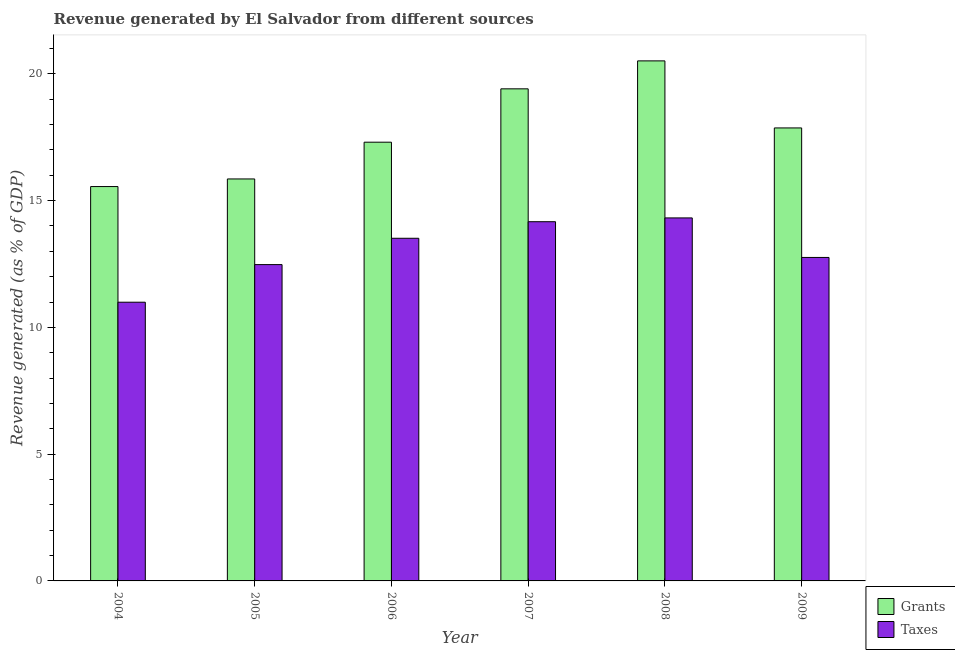How many different coloured bars are there?
Provide a succinct answer. 2. Are the number of bars on each tick of the X-axis equal?
Your answer should be very brief. Yes. How many bars are there on the 4th tick from the left?
Your response must be concise. 2. In how many cases, is the number of bars for a given year not equal to the number of legend labels?
Your answer should be very brief. 0. What is the revenue generated by taxes in 2006?
Offer a very short reply. 13.52. Across all years, what is the maximum revenue generated by taxes?
Your response must be concise. 14.32. Across all years, what is the minimum revenue generated by grants?
Keep it short and to the point. 15.56. What is the total revenue generated by taxes in the graph?
Offer a very short reply. 78.23. What is the difference between the revenue generated by grants in 2007 and that in 2009?
Your answer should be compact. 1.54. What is the difference between the revenue generated by grants in 2006 and the revenue generated by taxes in 2007?
Provide a succinct answer. -2.11. What is the average revenue generated by taxes per year?
Offer a terse response. 13.04. In the year 2004, what is the difference between the revenue generated by grants and revenue generated by taxes?
Provide a succinct answer. 0. What is the ratio of the revenue generated by taxes in 2005 to that in 2009?
Provide a short and direct response. 0.98. Is the revenue generated by taxes in 2006 less than that in 2009?
Provide a succinct answer. No. What is the difference between the highest and the second highest revenue generated by taxes?
Give a very brief answer. 0.15. What is the difference between the highest and the lowest revenue generated by grants?
Make the answer very short. 4.96. In how many years, is the revenue generated by grants greater than the average revenue generated by grants taken over all years?
Make the answer very short. 3. Is the sum of the revenue generated by grants in 2006 and 2009 greater than the maximum revenue generated by taxes across all years?
Provide a succinct answer. Yes. What does the 2nd bar from the left in 2007 represents?
Provide a succinct answer. Taxes. What does the 1st bar from the right in 2008 represents?
Offer a very short reply. Taxes. How many bars are there?
Ensure brevity in your answer.  12. Are all the bars in the graph horizontal?
Make the answer very short. No. How many years are there in the graph?
Your response must be concise. 6. Are the values on the major ticks of Y-axis written in scientific E-notation?
Ensure brevity in your answer.  No. Does the graph contain grids?
Your answer should be compact. No. How are the legend labels stacked?
Provide a succinct answer. Vertical. What is the title of the graph?
Give a very brief answer. Revenue generated by El Salvador from different sources. What is the label or title of the X-axis?
Offer a terse response. Year. What is the label or title of the Y-axis?
Offer a very short reply. Revenue generated (as % of GDP). What is the Revenue generated (as % of GDP) of Grants in 2004?
Your answer should be very brief. 15.56. What is the Revenue generated (as % of GDP) in Taxes in 2004?
Keep it short and to the point. 10.99. What is the Revenue generated (as % of GDP) in Grants in 2005?
Keep it short and to the point. 15.86. What is the Revenue generated (as % of GDP) of Taxes in 2005?
Give a very brief answer. 12.48. What is the Revenue generated (as % of GDP) of Grants in 2006?
Keep it short and to the point. 17.31. What is the Revenue generated (as % of GDP) in Taxes in 2006?
Give a very brief answer. 13.52. What is the Revenue generated (as % of GDP) of Grants in 2007?
Provide a short and direct response. 19.41. What is the Revenue generated (as % of GDP) in Taxes in 2007?
Your answer should be compact. 14.17. What is the Revenue generated (as % of GDP) of Grants in 2008?
Offer a terse response. 20.51. What is the Revenue generated (as % of GDP) in Taxes in 2008?
Your answer should be very brief. 14.32. What is the Revenue generated (as % of GDP) of Grants in 2009?
Keep it short and to the point. 17.87. What is the Revenue generated (as % of GDP) of Taxes in 2009?
Ensure brevity in your answer.  12.76. Across all years, what is the maximum Revenue generated (as % of GDP) in Grants?
Offer a very short reply. 20.51. Across all years, what is the maximum Revenue generated (as % of GDP) in Taxes?
Your answer should be compact. 14.32. Across all years, what is the minimum Revenue generated (as % of GDP) in Grants?
Offer a terse response. 15.56. Across all years, what is the minimum Revenue generated (as % of GDP) of Taxes?
Keep it short and to the point. 10.99. What is the total Revenue generated (as % of GDP) in Grants in the graph?
Your answer should be very brief. 106.51. What is the total Revenue generated (as % of GDP) in Taxes in the graph?
Give a very brief answer. 78.23. What is the difference between the Revenue generated (as % of GDP) of Taxes in 2004 and that in 2005?
Keep it short and to the point. -1.48. What is the difference between the Revenue generated (as % of GDP) in Grants in 2004 and that in 2006?
Provide a succinct answer. -1.75. What is the difference between the Revenue generated (as % of GDP) in Taxes in 2004 and that in 2006?
Keep it short and to the point. -2.52. What is the difference between the Revenue generated (as % of GDP) of Grants in 2004 and that in 2007?
Ensure brevity in your answer.  -3.85. What is the difference between the Revenue generated (as % of GDP) in Taxes in 2004 and that in 2007?
Your response must be concise. -3.18. What is the difference between the Revenue generated (as % of GDP) in Grants in 2004 and that in 2008?
Provide a short and direct response. -4.96. What is the difference between the Revenue generated (as % of GDP) in Taxes in 2004 and that in 2008?
Give a very brief answer. -3.32. What is the difference between the Revenue generated (as % of GDP) in Grants in 2004 and that in 2009?
Provide a short and direct response. -2.31. What is the difference between the Revenue generated (as % of GDP) in Taxes in 2004 and that in 2009?
Keep it short and to the point. -1.77. What is the difference between the Revenue generated (as % of GDP) of Grants in 2005 and that in 2006?
Provide a short and direct response. -1.45. What is the difference between the Revenue generated (as % of GDP) of Taxes in 2005 and that in 2006?
Make the answer very short. -1.04. What is the difference between the Revenue generated (as % of GDP) in Grants in 2005 and that in 2007?
Keep it short and to the point. -3.55. What is the difference between the Revenue generated (as % of GDP) of Taxes in 2005 and that in 2007?
Give a very brief answer. -1.69. What is the difference between the Revenue generated (as % of GDP) of Grants in 2005 and that in 2008?
Make the answer very short. -4.66. What is the difference between the Revenue generated (as % of GDP) of Taxes in 2005 and that in 2008?
Give a very brief answer. -1.84. What is the difference between the Revenue generated (as % of GDP) in Grants in 2005 and that in 2009?
Your answer should be very brief. -2.01. What is the difference between the Revenue generated (as % of GDP) of Taxes in 2005 and that in 2009?
Your answer should be very brief. -0.28. What is the difference between the Revenue generated (as % of GDP) of Grants in 2006 and that in 2007?
Your answer should be compact. -2.11. What is the difference between the Revenue generated (as % of GDP) in Taxes in 2006 and that in 2007?
Provide a succinct answer. -0.65. What is the difference between the Revenue generated (as % of GDP) of Grants in 2006 and that in 2008?
Provide a succinct answer. -3.21. What is the difference between the Revenue generated (as % of GDP) of Taxes in 2006 and that in 2008?
Your response must be concise. -0.8. What is the difference between the Revenue generated (as % of GDP) of Grants in 2006 and that in 2009?
Offer a terse response. -0.56. What is the difference between the Revenue generated (as % of GDP) in Taxes in 2006 and that in 2009?
Your response must be concise. 0.76. What is the difference between the Revenue generated (as % of GDP) in Grants in 2007 and that in 2008?
Offer a very short reply. -1.1. What is the difference between the Revenue generated (as % of GDP) of Taxes in 2007 and that in 2008?
Provide a succinct answer. -0.15. What is the difference between the Revenue generated (as % of GDP) in Grants in 2007 and that in 2009?
Keep it short and to the point. 1.54. What is the difference between the Revenue generated (as % of GDP) of Taxes in 2007 and that in 2009?
Your answer should be compact. 1.41. What is the difference between the Revenue generated (as % of GDP) in Grants in 2008 and that in 2009?
Offer a terse response. 2.64. What is the difference between the Revenue generated (as % of GDP) of Taxes in 2008 and that in 2009?
Keep it short and to the point. 1.56. What is the difference between the Revenue generated (as % of GDP) of Grants in 2004 and the Revenue generated (as % of GDP) of Taxes in 2005?
Give a very brief answer. 3.08. What is the difference between the Revenue generated (as % of GDP) of Grants in 2004 and the Revenue generated (as % of GDP) of Taxes in 2006?
Ensure brevity in your answer.  2.04. What is the difference between the Revenue generated (as % of GDP) of Grants in 2004 and the Revenue generated (as % of GDP) of Taxes in 2007?
Provide a succinct answer. 1.39. What is the difference between the Revenue generated (as % of GDP) of Grants in 2004 and the Revenue generated (as % of GDP) of Taxes in 2008?
Ensure brevity in your answer.  1.24. What is the difference between the Revenue generated (as % of GDP) of Grants in 2004 and the Revenue generated (as % of GDP) of Taxes in 2009?
Make the answer very short. 2.8. What is the difference between the Revenue generated (as % of GDP) in Grants in 2005 and the Revenue generated (as % of GDP) in Taxes in 2006?
Make the answer very short. 2.34. What is the difference between the Revenue generated (as % of GDP) in Grants in 2005 and the Revenue generated (as % of GDP) in Taxes in 2007?
Offer a very short reply. 1.69. What is the difference between the Revenue generated (as % of GDP) of Grants in 2005 and the Revenue generated (as % of GDP) of Taxes in 2008?
Your response must be concise. 1.54. What is the difference between the Revenue generated (as % of GDP) of Grants in 2005 and the Revenue generated (as % of GDP) of Taxes in 2009?
Your answer should be very brief. 3.1. What is the difference between the Revenue generated (as % of GDP) in Grants in 2006 and the Revenue generated (as % of GDP) in Taxes in 2007?
Provide a short and direct response. 3.14. What is the difference between the Revenue generated (as % of GDP) in Grants in 2006 and the Revenue generated (as % of GDP) in Taxes in 2008?
Ensure brevity in your answer.  2.99. What is the difference between the Revenue generated (as % of GDP) in Grants in 2006 and the Revenue generated (as % of GDP) in Taxes in 2009?
Ensure brevity in your answer.  4.55. What is the difference between the Revenue generated (as % of GDP) in Grants in 2007 and the Revenue generated (as % of GDP) in Taxes in 2008?
Your answer should be compact. 5.09. What is the difference between the Revenue generated (as % of GDP) of Grants in 2007 and the Revenue generated (as % of GDP) of Taxes in 2009?
Give a very brief answer. 6.65. What is the difference between the Revenue generated (as % of GDP) of Grants in 2008 and the Revenue generated (as % of GDP) of Taxes in 2009?
Your response must be concise. 7.75. What is the average Revenue generated (as % of GDP) of Grants per year?
Provide a short and direct response. 17.75. What is the average Revenue generated (as % of GDP) in Taxes per year?
Provide a succinct answer. 13.04. In the year 2004, what is the difference between the Revenue generated (as % of GDP) of Grants and Revenue generated (as % of GDP) of Taxes?
Give a very brief answer. 4.56. In the year 2005, what is the difference between the Revenue generated (as % of GDP) in Grants and Revenue generated (as % of GDP) in Taxes?
Offer a very short reply. 3.38. In the year 2006, what is the difference between the Revenue generated (as % of GDP) of Grants and Revenue generated (as % of GDP) of Taxes?
Give a very brief answer. 3.79. In the year 2007, what is the difference between the Revenue generated (as % of GDP) in Grants and Revenue generated (as % of GDP) in Taxes?
Your response must be concise. 5.24. In the year 2008, what is the difference between the Revenue generated (as % of GDP) in Grants and Revenue generated (as % of GDP) in Taxes?
Offer a terse response. 6.19. In the year 2009, what is the difference between the Revenue generated (as % of GDP) of Grants and Revenue generated (as % of GDP) of Taxes?
Your answer should be very brief. 5.11. What is the ratio of the Revenue generated (as % of GDP) of Grants in 2004 to that in 2005?
Keep it short and to the point. 0.98. What is the ratio of the Revenue generated (as % of GDP) in Taxes in 2004 to that in 2005?
Make the answer very short. 0.88. What is the ratio of the Revenue generated (as % of GDP) of Grants in 2004 to that in 2006?
Ensure brevity in your answer.  0.9. What is the ratio of the Revenue generated (as % of GDP) in Taxes in 2004 to that in 2006?
Offer a terse response. 0.81. What is the ratio of the Revenue generated (as % of GDP) of Grants in 2004 to that in 2007?
Ensure brevity in your answer.  0.8. What is the ratio of the Revenue generated (as % of GDP) in Taxes in 2004 to that in 2007?
Provide a short and direct response. 0.78. What is the ratio of the Revenue generated (as % of GDP) in Grants in 2004 to that in 2008?
Provide a short and direct response. 0.76. What is the ratio of the Revenue generated (as % of GDP) in Taxes in 2004 to that in 2008?
Your answer should be very brief. 0.77. What is the ratio of the Revenue generated (as % of GDP) of Grants in 2004 to that in 2009?
Offer a terse response. 0.87. What is the ratio of the Revenue generated (as % of GDP) in Taxes in 2004 to that in 2009?
Your response must be concise. 0.86. What is the ratio of the Revenue generated (as % of GDP) in Grants in 2005 to that in 2006?
Offer a very short reply. 0.92. What is the ratio of the Revenue generated (as % of GDP) of Taxes in 2005 to that in 2006?
Give a very brief answer. 0.92. What is the ratio of the Revenue generated (as % of GDP) of Grants in 2005 to that in 2007?
Keep it short and to the point. 0.82. What is the ratio of the Revenue generated (as % of GDP) of Taxes in 2005 to that in 2007?
Provide a short and direct response. 0.88. What is the ratio of the Revenue generated (as % of GDP) in Grants in 2005 to that in 2008?
Provide a succinct answer. 0.77. What is the ratio of the Revenue generated (as % of GDP) in Taxes in 2005 to that in 2008?
Your answer should be compact. 0.87. What is the ratio of the Revenue generated (as % of GDP) in Grants in 2005 to that in 2009?
Your response must be concise. 0.89. What is the ratio of the Revenue generated (as % of GDP) in Taxes in 2005 to that in 2009?
Your answer should be compact. 0.98. What is the ratio of the Revenue generated (as % of GDP) in Grants in 2006 to that in 2007?
Ensure brevity in your answer.  0.89. What is the ratio of the Revenue generated (as % of GDP) in Taxes in 2006 to that in 2007?
Offer a very short reply. 0.95. What is the ratio of the Revenue generated (as % of GDP) in Grants in 2006 to that in 2008?
Provide a succinct answer. 0.84. What is the ratio of the Revenue generated (as % of GDP) in Taxes in 2006 to that in 2008?
Provide a short and direct response. 0.94. What is the ratio of the Revenue generated (as % of GDP) in Grants in 2006 to that in 2009?
Your response must be concise. 0.97. What is the ratio of the Revenue generated (as % of GDP) of Taxes in 2006 to that in 2009?
Provide a succinct answer. 1.06. What is the ratio of the Revenue generated (as % of GDP) of Grants in 2007 to that in 2008?
Provide a short and direct response. 0.95. What is the ratio of the Revenue generated (as % of GDP) in Grants in 2007 to that in 2009?
Provide a short and direct response. 1.09. What is the ratio of the Revenue generated (as % of GDP) of Taxes in 2007 to that in 2009?
Make the answer very short. 1.11. What is the ratio of the Revenue generated (as % of GDP) of Grants in 2008 to that in 2009?
Your answer should be compact. 1.15. What is the ratio of the Revenue generated (as % of GDP) of Taxes in 2008 to that in 2009?
Your answer should be very brief. 1.12. What is the difference between the highest and the second highest Revenue generated (as % of GDP) of Grants?
Make the answer very short. 1.1. What is the difference between the highest and the second highest Revenue generated (as % of GDP) in Taxes?
Keep it short and to the point. 0.15. What is the difference between the highest and the lowest Revenue generated (as % of GDP) in Grants?
Keep it short and to the point. 4.96. What is the difference between the highest and the lowest Revenue generated (as % of GDP) in Taxes?
Provide a short and direct response. 3.32. 